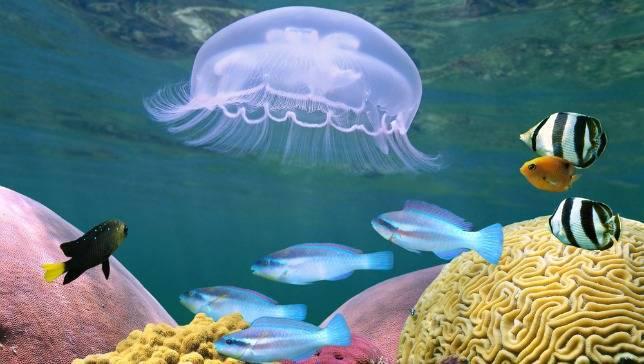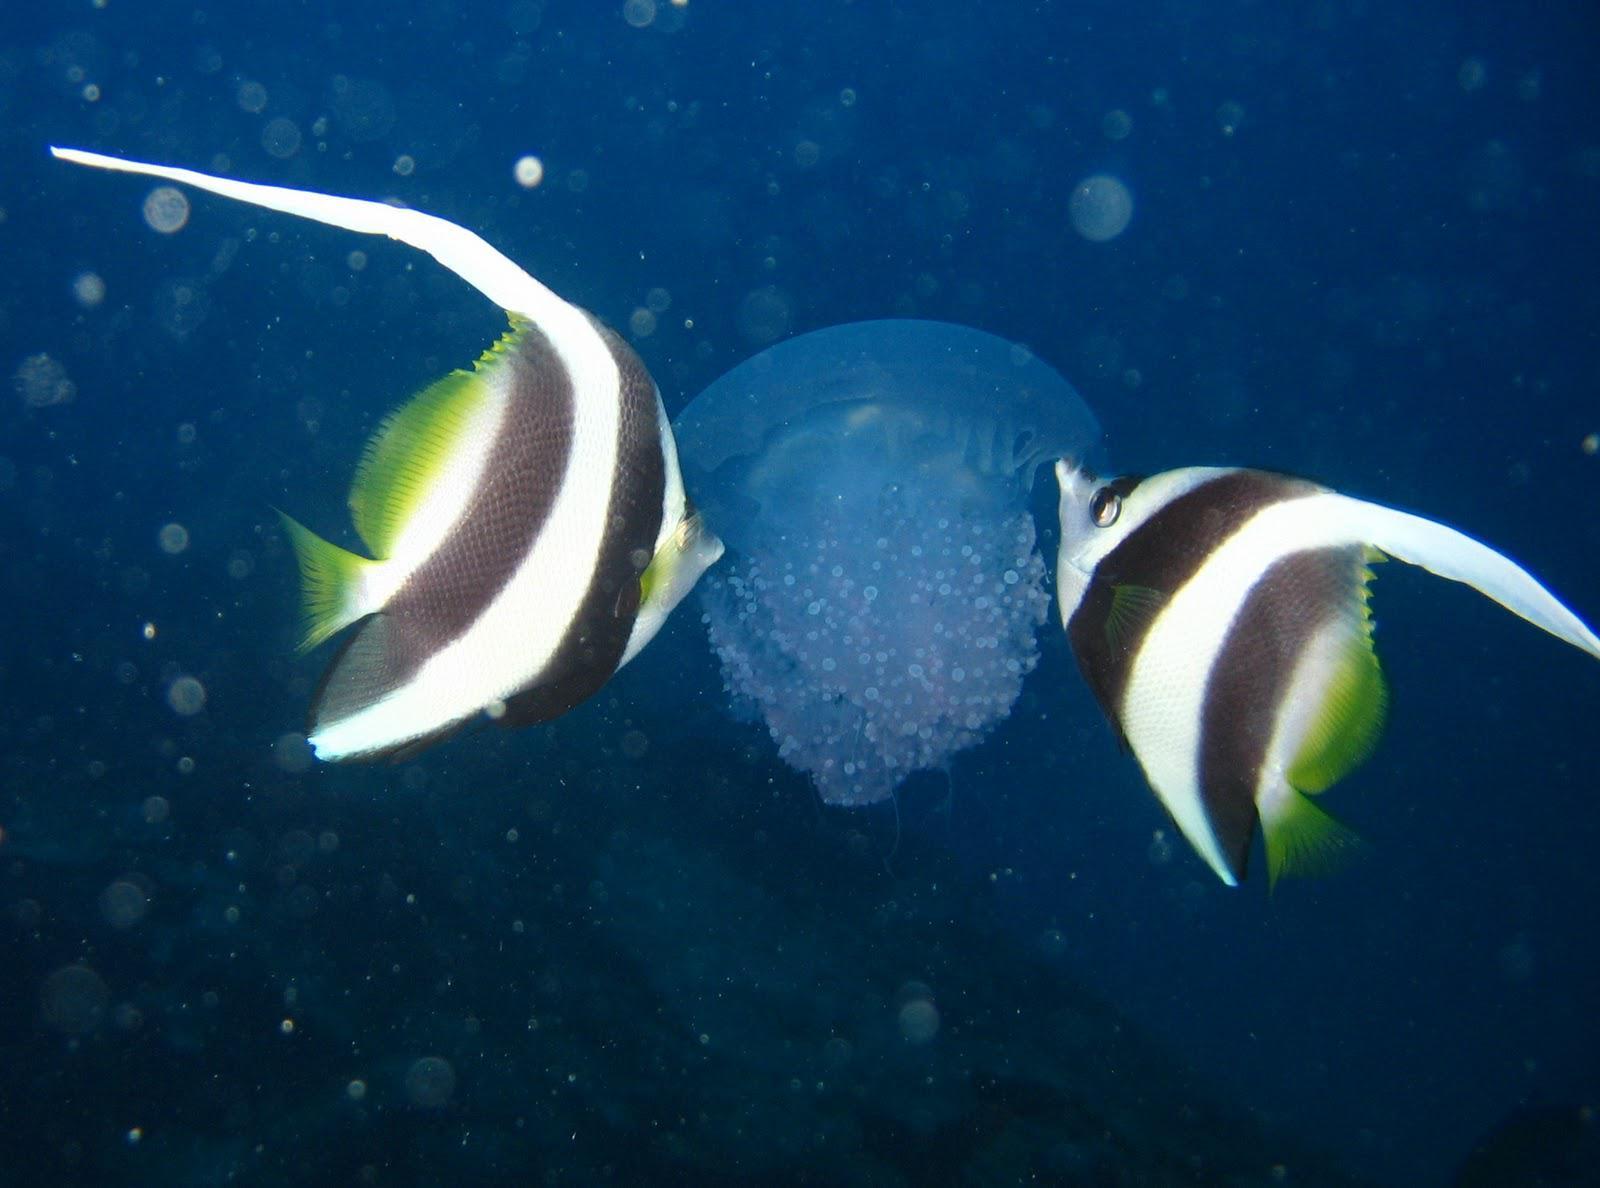The first image is the image on the left, the second image is the image on the right. Considering the images on both sides, is "sunlight can be seen in the surface ripples of the image on the left" valid? Answer yes or no. Yes. The first image is the image on the left, the second image is the image on the right. Given the left and right images, does the statement "Left image shows one animal to the left of a violet-tinted jellyfish." hold true? Answer yes or no. No. 